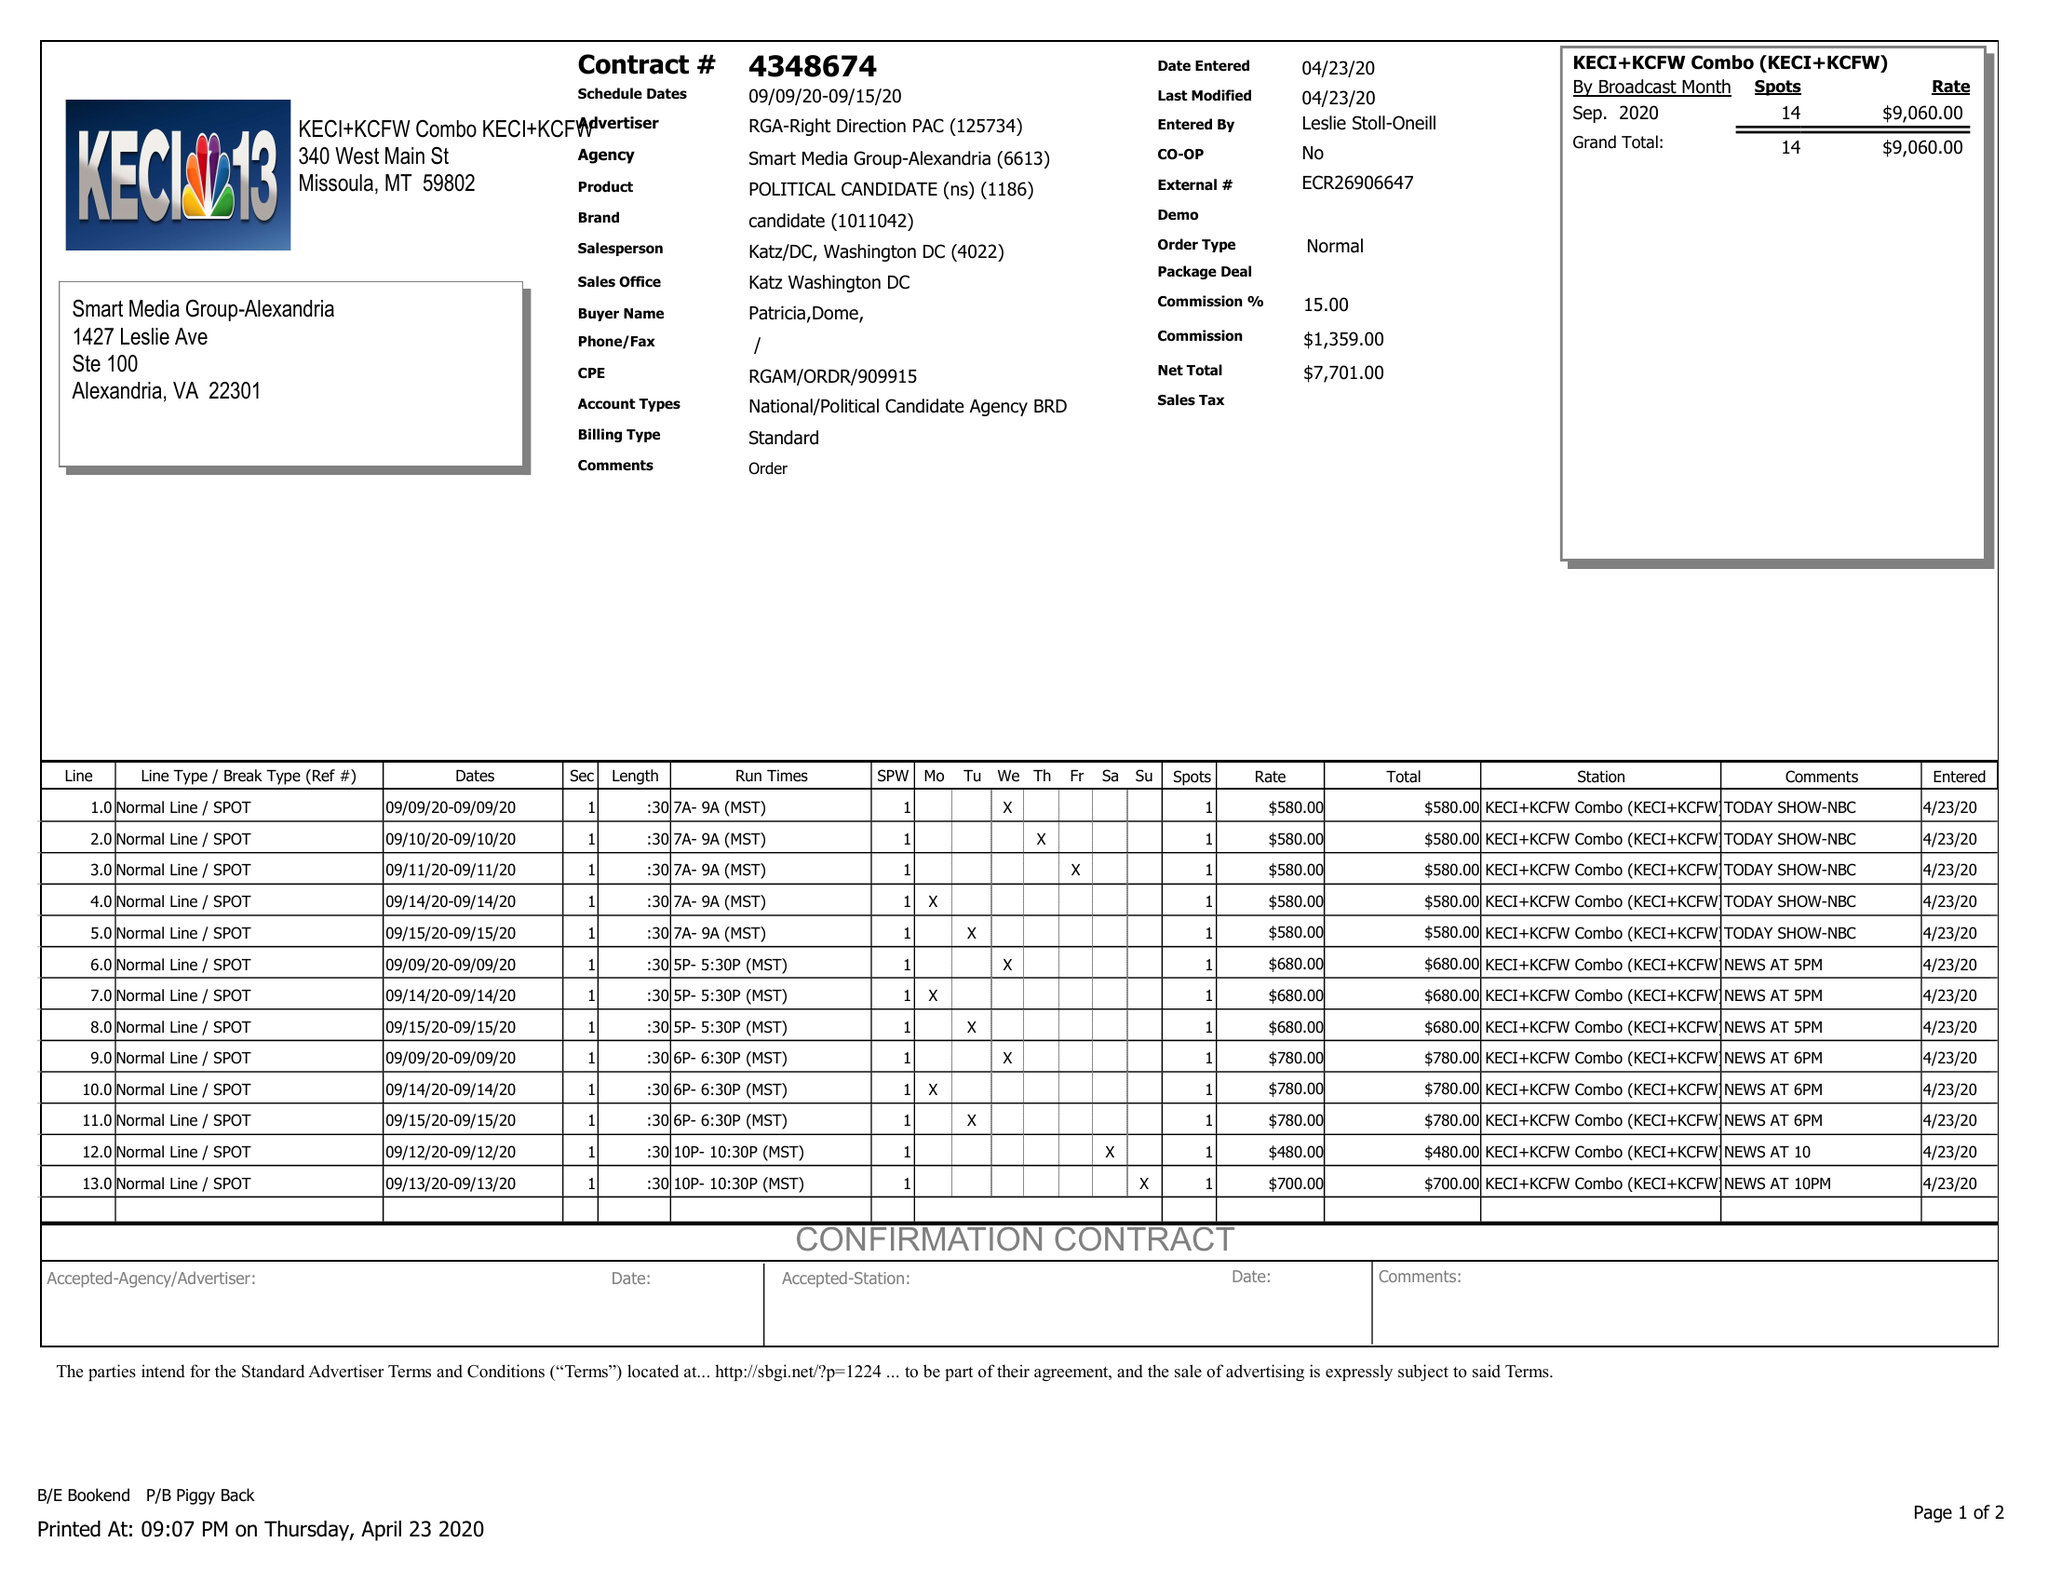What is the value for the gross_amount?
Answer the question using a single word or phrase. 9060.00 